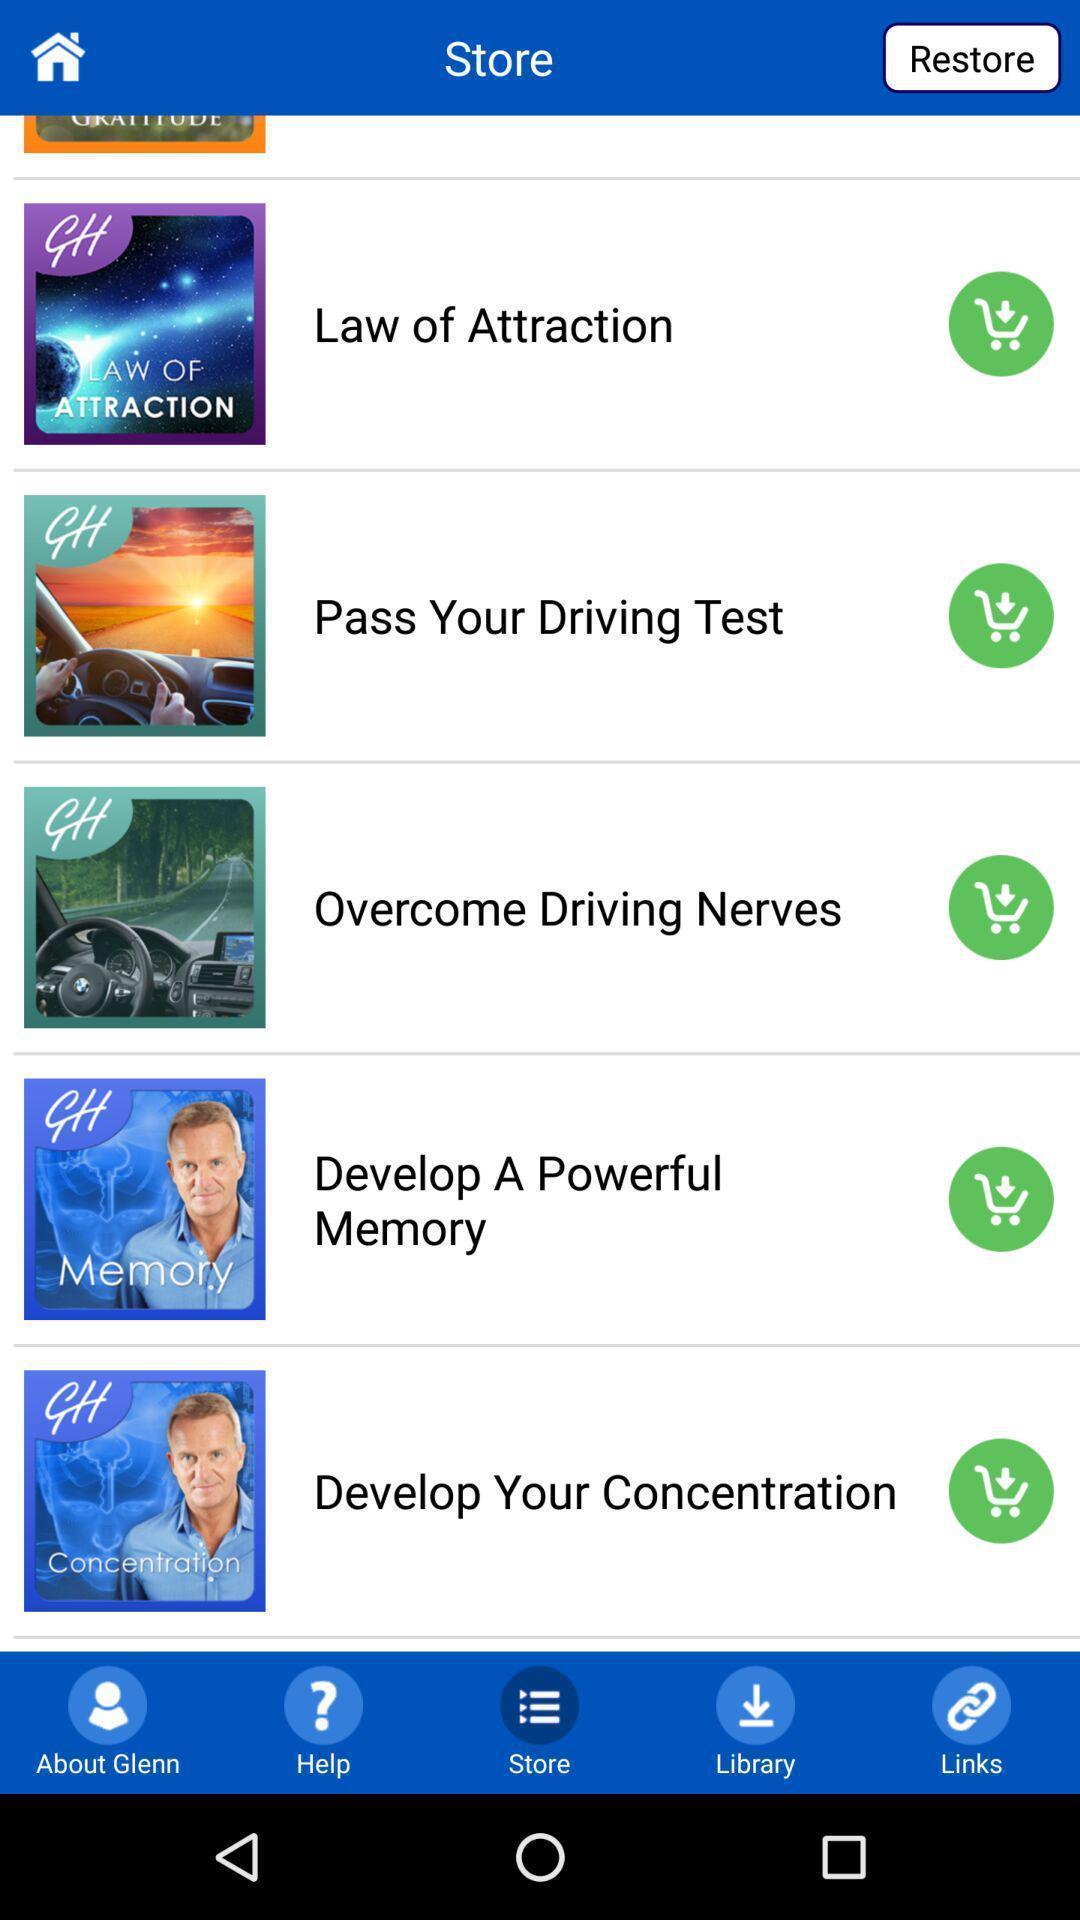Describe the visual elements of this screenshot. Page displaying various options in shopping application. 